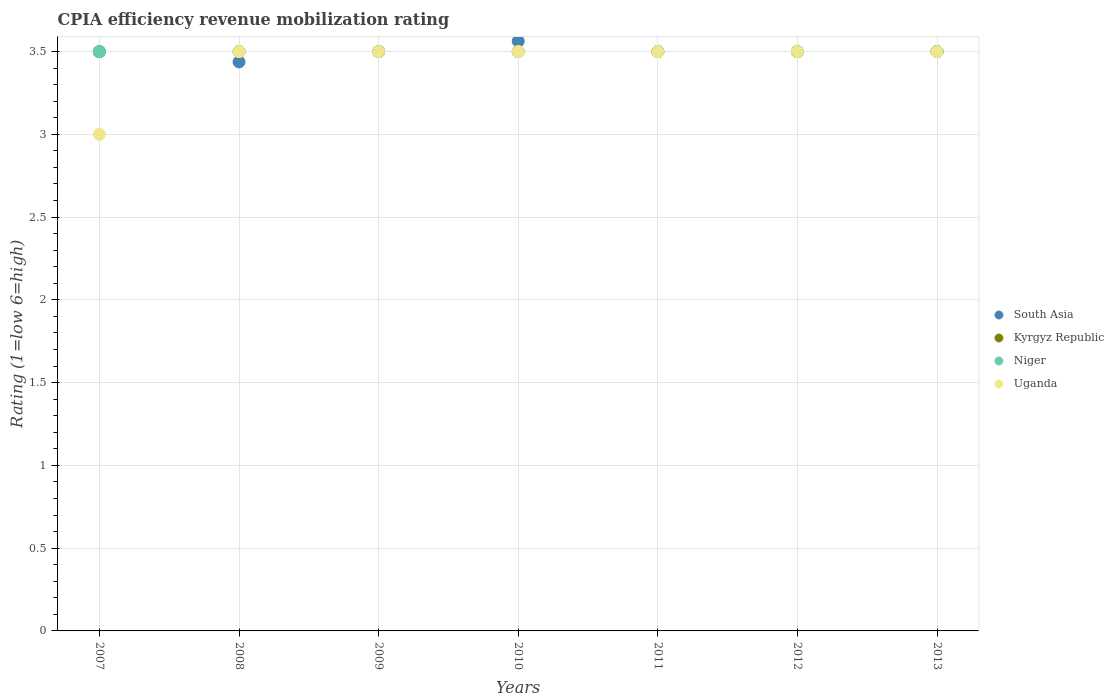Is the number of dotlines equal to the number of legend labels?
Provide a short and direct response. Yes. What is the CPIA rating in Uganda in 2013?
Provide a short and direct response. 3.5. Across all years, what is the maximum CPIA rating in South Asia?
Ensure brevity in your answer.  3.56. Across all years, what is the minimum CPIA rating in Uganda?
Keep it short and to the point. 3. In which year was the CPIA rating in Uganda minimum?
Provide a succinct answer. 2007. What is the difference between the CPIA rating in Niger in 2009 and that in 2010?
Give a very brief answer. 0. What is the difference between the CPIA rating in Niger in 2013 and the CPIA rating in Kyrgyz Republic in 2008?
Ensure brevity in your answer.  0. What is the average CPIA rating in Uganda per year?
Offer a very short reply. 3.43. In how many years, is the CPIA rating in South Asia greater than 2.8?
Provide a short and direct response. 7. What is the ratio of the CPIA rating in Kyrgyz Republic in 2009 to that in 2011?
Your answer should be very brief. 1. Is the CPIA rating in Uganda in 2007 less than that in 2010?
Keep it short and to the point. Yes. Is the difference between the CPIA rating in Uganda in 2010 and 2012 greater than the difference between the CPIA rating in South Asia in 2010 and 2012?
Keep it short and to the point. No. What is the difference between the highest and the lowest CPIA rating in Uganda?
Your response must be concise. 0.5. Does the CPIA rating in South Asia monotonically increase over the years?
Provide a succinct answer. No. What is the difference between two consecutive major ticks on the Y-axis?
Keep it short and to the point. 0.5. Does the graph contain any zero values?
Make the answer very short. No. Where does the legend appear in the graph?
Offer a very short reply. Center right. How many legend labels are there?
Ensure brevity in your answer.  4. How are the legend labels stacked?
Provide a short and direct response. Vertical. What is the title of the graph?
Offer a very short reply. CPIA efficiency revenue mobilization rating. What is the label or title of the X-axis?
Your answer should be compact. Years. What is the Rating (1=low 6=high) in South Asia in 2007?
Offer a terse response. 3.5. What is the Rating (1=low 6=high) in Kyrgyz Republic in 2007?
Your response must be concise. 3.5. What is the Rating (1=low 6=high) in Uganda in 2007?
Provide a short and direct response. 3. What is the Rating (1=low 6=high) of South Asia in 2008?
Make the answer very short. 3.44. What is the Rating (1=low 6=high) of Niger in 2008?
Your response must be concise. 3.5. What is the Rating (1=low 6=high) of Niger in 2009?
Your answer should be compact. 3.5. What is the Rating (1=low 6=high) of South Asia in 2010?
Your answer should be compact. 3.56. What is the Rating (1=low 6=high) in Kyrgyz Republic in 2010?
Ensure brevity in your answer.  3.5. What is the Rating (1=low 6=high) in Niger in 2010?
Offer a terse response. 3.5. What is the Rating (1=low 6=high) of Uganda in 2010?
Your answer should be very brief. 3.5. What is the Rating (1=low 6=high) in Uganda in 2011?
Your response must be concise. 3.5. What is the Rating (1=low 6=high) in South Asia in 2012?
Offer a terse response. 3.5. What is the Rating (1=low 6=high) of South Asia in 2013?
Keep it short and to the point. 3.5. What is the Rating (1=low 6=high) of Kyrgyz Republic in 2013?
Provide a succinct answer. 3.5. Across all years, what is the maximum Rating (1=low 6=high) of South Asia?
Your answer should be very brief. 3.56. Across all years, what is the maximum Rating (1=low 6=high) of Niger?
Ensure brevity in your answer.  3.5. Across all years, what is the maximum Rating (1=low 6=high) of Uganda?
Your response must be concise. 3.5. Across all years, what is the minimum Rating (1=low 6=high) of South Asia?
Your answer should be very brief. 3.44. Across all years, what is the minimum Rating (1=low 6=high) in Kyrgyz Republic?
Make the answer very short. 3.5. Across all years, what is the minimum Rating (1=low 6=high) in Uganda?
Offer a very short reply. 3. What is the total Rating (1=low 6=high) of Kyrgyz Republic in the graph?
Keep it short and to the point. 24.5. What is the difference between the Rating (1=low 6=high) of South Asia in 2007 and that in 2008?
Provide a succinct answer. 0.06. What is the difference between the Rating (1=low 6=high) in Kyrgyz Republic in 2007 and that in 2008?
Your answer should be compact. 0. What is the difference between the Rating (1=low 6=high) of South Asia in 2007 and that in 2009?
Provide a short and direct response. 0. What is the difference between the Rating (1=low 6=high) in Kyrgyz Republic in 2007 and that in 2009?
Provide a succinct answer. 0. What is the difference between the Rating (1=low 6=high) in Niger in 2007 and that in 2009?
Provide a succinct answer. 0. What is the difference between the Rating (1=low 6=high) in Uganda in 2007 and that in 2009?
Provide a short and direct response. -0.5. What is the difference between the Rating (1=low 6=high) in South Asia in 2007 and that in 2010?
Ensure brevity in your answer.  -0.06. What is the difference between the Rating (1=low 6=high) in Niger in 2007 and that in 2010?
Your response must be concise. 0. What is the difference between the Rating (1=low 6=high) of Uganda in 2007 and that in 2010?
Give a very brief answer. -0.5. What is the difference between the Rating (1=low 6=high) of South Asia in 2007 and that in 2011?
Provide a succinct answer. 0. What is the difference between the Rating (1=low 6=high) of Niger in 2007 and that in 2011?
Offer a terse response. 0. What is the difference between the Rating (1=low 6=high) in South Asia in 2007 and that in 2012?
Give a very brief answer. 0. What is the difference between the Rating (1=low 6=high) of Kyrgyz Republic in 2007 and that in 2012?
Offer a terse response. 0. What is the difference between the Rating (1=low 6=high) of Niger in 2007 and that in 2012?
Your answer should be very brief. 0. What is the difference between the Rating (1=low 6=high) in Uganda in 2007 and that in 2013?
Your answer should be very brief. -0.5. What is the difference between the Rating (1=low 6=high) in South Asia in 2008 and that in 2009?
Your answer should be compact. -0.06. What is the difference between the Rating (1=low 6=high) in Kyrgyz Republic in 2008 and that in 2009?
Make the answer very short. 0. What is the difference between the Rating (1=low 6=high) of Niger in 2008 and that in 2009?
Your answer should be very brief. 0. What is the difference between the Rating (1=low 6=high) of South Asia in 2008 and that in 2010?
Offer a terse response. -0.12. What is the difference between the Rating (1=low 6=high) of South Asia in 2008 and that in 2011?
Provide a succinct answer. -0.06. What is the difference between the Rating (1=low 6=high) of Kyrgyz Republic in 2008 and that in 2011?
Your answer should be compact. 0. What is the difference between the Rating (1=low 6=high) of Niger in 2008 and that in 2011?
Provide a succinct answer. 0. What is the difference between the Rating (1=low 6=high) of South Asia in 2008 and that in 2012?
Ensure brevity in your answer.  -0.06. What is the difference between the Rating (1=low 6=high) in Kyrgyz Republic in 2008 and that in 2012?
Your response must be concise. 0. What is the difference between the Rating (1=low 6=high) in South Asia in 2008 and that in 2013?
Offer a very short reply. -0.06. What is the difference between the Rating (1=low 6=high) of Niger in 2008 and that in 2013?
Give a very brief answer. 0. What is the difference between the Rating (1=low 6=high) of South Asia in 2009 and that in 2010?
Provide a short and direct response. -0.06. What is the difference between the Rating (1=low 6=high) of Kyrgyz Republic in 2009 and that in 2011?
Your answer should be very brief. 0. What is the difference between the Rating (1=low 6=high) of Niger in 2009 and that in 2011?
Ensure brevity in your answer.  0. What is the difference between the Rating (1=low 6=high) of Uganda in 2009 and that in 2011?
Keep it short and to the point. 0. What is the difference between the Rating (1=low 6=high) of Uganda in 2009 and that in 2012?
Offer a terse response. 0. What is the difference between the Rating (1=low 6=high) in Kyrgyz Republic in 2009 and that in 2013?
Provide a short and direct response. 0. What is the difference between the Rating (1=low 6=high) of Uganda in 2009 and that in 2013?
Your answer should be compact. 0. What is the difference between the Rating (1=low 6=high) of South Asia in 2010 and that in 2011?
Offer a very short reply. 0.06. What is the difference between the Rating (1=low 6=high) in Niger in 2010 and that in 2011?
Provide a short and direct response. 0. What is the difference between the Rating (1=low 6=high) of South Asia in 2010 and that in 2012?
Ensure brevity in your answer.  0.06. What is the difference between the Rating (1=low 6=high) in Kyrgyz Republic in 2010 and that in 2012?
Your response must be concise. 0. What is the difference between the Rating (1=low 6=high) in Niger in 2010 and that in 2012?
Ensure brevity in your answer.  0. What is the difference between the Rating (1=low 6=high) in Uganda in 2010 and that in 2012?
Offer a terse response. 0. What is the difference between the Rating (1=low 6=high) in South Asia in 2010 and that in 2013?
Offer a terse response. 0.06. What is the difference between the Rating (1=low 6=high) of Kyrgyz Republic in 2010 and that in 2013?
Keep it short and to the point. 0. What is the difference between the Rating (1=low 6=high) of Niger in 2010 and that in 2013?
Provide a short and direct response. 0. What is the difference between the Rating (1=low 6=high) of Uganda in 2010 and that in 2013?
Keep it short and to the point. 0. What is the difference between the Rating (1=low 6=high) of South Asia in 2011 and that in 2012?
Offer a very short reply. 0. What is the difference between the Rating (1=low 6=high) of Kyrgyz Republic in 2011 and that in 2012?
Your answer should be compact. 0. What is the difference between the Rating (1=low 6=high) of Uganda in 2011 and that in 2012?
Offer a very short reply. 0. What is the difference between the Rating (1=low 6=high) of South Asia in 2011 and that in 2013?
Provide a succinct answer. 0. What is the difference between the Rating (1=low 6=high) of Kyrgyz Republic in 2011 and that in 2013?
Keep it short and to the point. 0. What is the difference between the Rating (1=low 6=high) of Uganda in 2011 and that in 2013?
Provide a short and direct response. 0. What is the difference between the Rating (1=low 6=high) in South Asia in 2012 and that in 2013?
Offer a terse response. 0. What is the difference between the Rating (1=low 6=high) in Uganda in 2012 and that in 2013?
Provide a succinct answer. 0. What is the difference between the Rating (1=low 6=high) in South Asia in 2007 and the Rating (1=low 6=high) in Niger in 2008?
Provide a succinct answer. 0. What is the difference between the Rating (1=low 6=high) in South Asia in 2007 and the Rating (1=low 6=high) in Uganda in 2008?
Give a very brief answer. 0. What is the difference between the Rating (1=low 6=high) in Kyrgyz Republic in 2007 and the Rating (1=low 6=high) in Niger in 2008?
Your answer should be compact. 0. What is the difference between the Rating (1=low 6=high) of Kyrgyz Republic in 2007 and the Rating (1=low 6=high) of Uganda in 2008?
Your answer should be very brief. 0. What is the difference between the Rating (1=low 6=high) in Niger in 2007 and the Rating (1=low 6=high) in Uganda in 2008?
Ensure brevity in your answer.  0. What is the difference between the Rating (1=low 6=high) in South Asia in 2007 and the Rating (1=low 6=high) in Kyrgyz Republic in 2009?
Your response must be concise. 0. What is the difference between the Rating (1=low 6=high) of South Asia in 2007 and the Rating (1=low 6=high) of Uganda in 2009?
Offer a very short reply. 0. What is the difference between the Rating (1=low 6=high) of Kyrgyz Republic in 2007 and the Rating (1=low 6=high) of Uganda in 2009?
Your response must be concise. 0. What is the difference between the Rating (1=low 6=high) in South Asia in 2007 and the Rating (1=low 6=high) in Kyrgyz Republic in 2010?
Offer a very short reply. 0. What is the difference between the Rating (1=low 6=high) of Niger in 2007 and the Rating (1=low 6=high) of Uganda in 2010?
Your answer should be very brief. 0. What is the difference between the Rating (1=low 6=high) of South Asia in 2007 and the Rating (1=low 6=high) of Niger in 2011?
Your answer should be very brief. 0. What is the difference between the Rating (1=low 6=high) in South Asia in 2007 and the Rating (1=low 6=high) in Uganda in 2011?
Keep it short and to the point. 0. What is the difference between the Rating (1=low 6=high) of South Asia in 2007 and the Rating (1=low 6=high) of Niger in 2012?
Provide a succinct answer. 0. What is the difference between the Rating (1=low 6=high) of South Asia in 2007 and the Rating (1=low 6=high) of Uganda in 2012?
Ensure brevity in your answer.  0. What is the difference between the Rating (1=low 6=high) of Kyrgyz Republic in 2007 and the Rating (1=low 6=high) of Niger in 2012?
Offer a terse response. 0. What is the difference between the Rating (1=low 6=high) of South Asia in 2007 and the Rating (1=low 6=high) of Niger in 2013?
Ensure brevity in your answer.  0. What is the difference between the Rating (1=low 6=high) of South Asia in 2007 and the Rating (1=low 6=high) of Uganda in 2013?
Offer a terse response. 0. What is the difference between the Rating (1=low 6=high) of Kyrgyz Republic in 2007 and the Rating (1=low 6=high) of Uganda in 2013?
Your answer should be very brief. 0. What is the difference between the Rating (1=low 6=high) in Niger in 2007 and the Rating (1=low 6=high) in Uganda in 2013?
Offer a very short reply. 0. What is the difference between the Rating (1=low 6=high) in South Asia in 2008 and the Rating (1=low 6=high) in Kyrgyz Republic in 2009?
Your answer should be compact. -0.06. What is the difference between the Rating (1=low 6=high) in South Asia in 2008 and the Rating (1=low 6=high) in Niger in 2009?
Provide a short and direct response. -0.06. What is the difference between the Rating (1=low 6=high) in South Asia in 2008 and the Rating (1=low 6=high) in Uganda in 2009?
Provide a succinct answer. -0.06. What is the difference between the Rating (1=low 6=high) in Kyrgyz Republic in 2008 and the Rating (1=low 6=high) in Uganda in 2009?
Ensure brevity in your answer.  0. What is the difference between the Rating (1=low 6=high) of Niger in 2008 and the Rating (1=low 6=high) of Uganda in 2009?
Offer a terse response. 0. What is the difference between the Rating (1=low 6=high) of South Asia in 2008 and the Rating (1=low 6=high) of Kyrgyz Republic in 2010?
Make the answer very short. -0.06. What is the difference between the Rating (1=low 6=high) of South Asia in 2008 and the Rating (1=low 6=high) of Niger in 2010?
Keep it short and to the point. -0.06. What is the difference between the Rating (1=low 6=high) in South Asia in 2008 and the Rating (1=low 6=high) in Uganda in 2010?
Ensure brevity in your answer.  -0.06. What is the difference between the Rating (1=low 6=high) in Kyrgyz Republic in 2008 and the Rating (1=low 6=high) in Uganda in 2010?
Keep it short and to the point. 0. What is the difference between the Rating (1=low 6=high) in Niger in 2008 and the Rating (1=low 6=high) in Uganda in 2010?
Your response must be concise. 0. What is the difference between the Rating (1=low 6=high) of South Asia in 2008 and the Rating (1=low 6=high) of Kyrgyz Republic in 2011?
Offer a terse response. -0.06. What is the difference between the Rating (1=low 6=high) in South Asia in 2008 and the Rating (1=low 6=high) in Niger in 2011?
Your answer should be compact. -0.06. What is the difference between the Rating (1=low 6=high) of South Asia in 2008 and the Rating (1=low 6=high) of Uganda in 2011?
Your response must be concise. -0.06. What is the difference between the Rating (1=low 6=high) in Kyrgyz Republic in 2008 and the Rating (1=low 6=high) in Niger in 2011?
Offer a very short reply. 0. What is the difference between the Rating (1=low 6=high) of South Asia in 2008 and the Rating (1=low 6=high) of Kyrgyz Republic in 2012?
Keep it short and to the point. -0.06. What is the difference between the Rating (1=low 6=high) of South Asia in 2008 and the Rating (1=low 6=high) of Niger in 2012?
Provide a succinct answer. -0.06. What is the difference between the Rating (1=low 6=high) in South Asia in 2008 and the Rating (1=low 6=high) in Uganda in 2012?
Keep it short and to the point. -0.06. What is the difference between the Rating (1=low 6=high) in Kyrgyz Republic in 2008 and the Rating (1=low 6=high) in Uganda in 2012?
Your answer should be very brief. 0. What is the difference between the Rating (1=low 6=high) of Niger in 2008 and the Rating (1=low 6=high) of Uganda in 2012?
Provide a short and direct response. 0. What is the difference between the Rating (1=low 6=high) of South Asia in 2008 and the Rating (1=low 6=high) of Kyrgyz Republic in 2013?
Your answer should be compact. -0.06. What is the difference between the Rating (1=low 6=high) of South Asia in 2008 and the Rating (1=low 6=high) of Niger in 2013?
Keep it short and to the point. -0.06. What is the difference between the Rating (1=low 6=high) of South Asia in 2008 and the Rating (1=low 6=high) of Uganda in 2013?
Your response must be concise. -0.06. What is the difference between the Rating (1=low 6=high) in Kyrgyz Republic in 2008 and the Rating (1=low 6=high) in Niger in 2013?
Provide a succinct answer. 0. What is the difference between the Rating (1=low 6=high) of Niger in 2008 and the Rating (1=low 6=high) of Uganda in 2013?
Your response must be concise. 0. What is the difference between the Rating (1=low 6=high) of South Asia in 2009 and the Rating (1=low 6=high) of Kyrgyz Republic in 2010?
Offer a terse response. 0. What is the difference between the Rating (1=low 6=high) in Kyrgyz Republic in 2009 and the Rating (1=low 6=high) in Uganda in 2010?
Ensure brevity in your answer.  0. What is the difference between the Rating (1=low 6=high) in Kyrgyz Republic in 2009 and the Rating (1=low 6=high) in Uganda in 2011?
Give a very brief answer. 0. What is the difference between the Rating (1=low 6=high) of Niger in 2009 and the Rating (1=low 6=high) of Uganda in 2011?
Your answer should be very brief. 0. What is the difference between the Rating (1=low 6=high) of South Asia in 2009 and the Rating (1=low 6=high) of Kyrgyz Republic in 2012?
Offer a terse response. 0. What is the difference between the Rating (1=low 6=high) of South Asia in 2009 and the Rating (1=low 6=high) of Niger in 2012?
Your answer should be compact. 0. What is the difference between the Rating (1=low 6=high) of South Asia in 2009 and the Rating (1=low 6=high) of Uganda in 2012?
Give a very brief answer. 0. What is the difference between the Rating (1=low 6=high) in Kyrgyz Republic in 2009 and the Rating (1=low 6=high) in Niger in 2012?
Your answer should be very brief. 0. What is the difference between the Rating (1=low 6=high) in South Asia in 2009 and the Rating (1=low 6=high) in Kyrgyz Republic in 2013?
Keep it short and to the point. 0. What is the difference between the Rating (1=low 6=high) of Kyrgyz Republic in 2009 and the Rating (1=low 6=high) of Niger in 2013?
Ensure brevity in your answer.  0. What is the difference between the Rating (1=low 6=high) in Niger in 2009 and the Rating (1=low 6=high) in Uganda in 2013?
Keep it short and to the point. 0. What is the difference between the Rating (1=low 6=high) in South Asia in 2010 and the Rating (1=low 6=high) in Kyrgyz Republic in 2011?
Your answer should be compact. 0.06. What is the difference between the Rating (1=low 6=high) in South Asia in 2010 and the Rating (1=low 6=high) in Niger in 2011?
Your answer should be compact. 0.06. What is the difference between the Rating (1=low 6=high) of South Asia in 2010 and the Rating (1=low 6=high) of Uganda in 2011?
Provide a short and direct response. 0.06. What is the difference between the Rating (1=low 6=high) of Kyrgyz Republic in 2010 and the Rating (1=low 6=high) of Uganda in 2011?
Offer a terse response. 0. What is the difference between the Rating (1=low 6=high) in South Asia in 2010 and the Rating (1=low 6=high) in Kyrgyz Republic in 2012?
Give a very brief answer. 0.06. What is the difference between the Rating (1=low 6=high) of South Asia in 2010 and the Rating (1=low 6=high) of Niger in 2012?
Ensure brevity in your answer.  0.06. What is the difference between the Rating (1=low 6=high) of South Asia in 2010 and the Rating (1=low 6=high) of Uganda in 2012?
Offer a very short reply. 0.06. What is the difference between the Rating (1=low 6=high) in Kyrgyz Republic in 2010 and the Rating (1=low 6=high) in Niger in 2012?
Your response must be concise. 0. What is the difference between the Rating (1=low 6=high) of South Asia in 2010 and the Rating (1=low 6=high) of Kyrgyz Republic in 2013?
Keep it short and to the point. 0.06. What is the difference between the Rating (1=low 6=high) of South Asia in 2010 and the Rating (1=low 6=high) of Niger in 2013?
Your response must be concise. 0.06. What is the difference between the Rating (1=low 6=high) in South Asia in 2010 and the Rating (1=low 6=high) in Uganda in 2013?
Ensure brevity in your answer.  0.06. What is the difference between the Rating (1=low 6=high) of Kyrgyz Republic in 2010 and the Rating (1=low 6=high) of Niger in 2013?
Your answer should be very brief. 0. What is the difference between the Rating (1=low 6=high) in Niger in 2010 and the Rating (1=low 6=high) in Uganda in 2013?
Ensure brevity in your answer.  0. What is the difference between the Rating (1=low 6=high) in Kyrgyz Republic in 2011 and the Rating (1=low 6=high) in Niger in 2012?
Offer a terse response. 0. What is the difference between the Rating (1=low 6=high) of South Asia in 2011 and the Rating (1=low 6=high) of Kyrgyz Republic in 2013?
Offer a terse response. 0. What is the difference between the Rating (1=low 6=high) in South Asia in 2011 and the Rating (1=low 6=high) in Uganda in 2013?
Ensure brevity in your answer.  0. What is the difference between the Rating (1=low 6=high) in South Asia in 2012 and the Rating (1=low 6=high) in Kyrgyz Republic in 2013?
Your answer should be very brief. 0. What is the difference between the Rating (1=low 6=high) in Kyrgyz Republic in 2012 and the Rating (1=low 6=high) in Niger in 2013?
Give a very brief answer. 0. What is the difference between the Rating (1=low 6=high) in Kyrgyz Republic in 2012 and the Rating (1=low 6=high) in Uganda in 2013?
Offer a terse response. 0. What is the average Rating (1=low 6=high) in Uganda per year?
Your answer should be very brief. 3.43. In the year 2007, what is the difference between the Rating (1=low 6=high) of South Asia and Rating (1=low 6=high) of Uganda?
Offer a very short reply. 0.5. In the year 2007, what is the difference between the Rating (1=low 6=high) of Kyrgyz Republic and Rating (1=low 6=high) of Niger?
Offer a very short reply. 0. In the year 2007, what is the difference between the Rating (1=low 6=high) in Niger and Rating (1=low 6=high) in Uganda?
Provide a succinct answer. 0.5. In the year 2008, what is the difference between the Rating (1=low 6=high) of South Asia and Rating (1=low 6=high) of Kyrgyz Republic?
Offer a very short reply. -0.06. In the year 2008, what is the difference between the Rating (1=low 6=high) in South Asia and Rating (1=low 6=high) in Niger?
Offer a terse response. -0.06. In the year 2008, what is the difference between the Rating (1=low 6=high) of South Asia and Rating (1=low 6=high) of Uganda?
Offer a terse response. -0.06. In the year 2008, what is the difference between the Rating (1=low 6=high) of Kyrgyz Republic and Rating (1=low 6=high) of Uganda?
Your answer should be very brief. 0. In the year 2009, what is the difference between the Rating (1=low 6=high) in South Asia and Rating (1=low 6=high) in Kyrgyz Republic?
Make the answer very short. 0. In the year 2009, what is the difference between the Rating (1=low 6=high) of South Asia and Rating (1=low 6=high) of Niger?
Your answer should be compact. 0. In the year 2010, what is the difference between the Rating (1=low 6=high) of South Asia and Rating (1=low 6=high) of Kyrgyz Republic?
Keep it short and to the point. 0.06. In the year 2010, what is the difference between the Rating (1=low 6=high) of South Asia and Rating (1=low 6=high) of Niger?
Give a very brief answer. 0.06. In the year 2010, what is the difference between the Rating (1=low 6=high) in South Asia and Rating (1=low 6=high) in Uganda?
Your answer should be compact. 0.06. In the year 2010, what is the difference between the Rating (1=low 6=high) of Kyrgyz Republic and Rating (1=low 6=high) of Niger?
Your answer should be compact. 0. In the year 2011, what is the difference between the Rating (1=low 6=high) in South Asia and Rating (1=low 6=high) in Uganda?
Make the answer very short. 0. In the year 2011, what is the difference between the Rating (1=low 6=high) in Kyrgyz Republic and Rating (1=low 6=high) in Niger?
Offer a very short reply. 0. In the year 2012, what is the difference between the Rating (1=low 6=high) of South Asia and Rating (1=low 6=high) of Niger?
Offer a very short reply. 0. In the year 2012, what is the difference between the Rating (1=low 6=high) of South Asia and Rating (1=low 6=high) of Uganda?
Your answer should be very brief. 0. In the year 2012, what is the difference between the Rating (1=low 6=high) in Kyrgyz Republic and Rating (1=low 6=high) in Uganda?
Your answer should be very brief. 0. In the year 2013, what is the difference between the Rating (1=low 6=high) of South Asia and Rating (1=low 6=high) of Niger?
Offer a terse response. 0. In the year 2013, what is the difference between the Rating (1=low 6=high) in South Asia and Rating (1=low 6=high) in Uganda?
Ensure brevity in your answer.  0. In the year 2013, what is the difference between the Rating (1=low 6=high) of Kyrgyz Republic and Rating (1=low 6=high) of Niger?
Ensure brevity in your answer.  0. In the year 2013, what is the difference between the Rating (1=low 6=high) in Niger and Rating (1=low 6=high) in Uganda?
Provide a short and direct response. 0. What is the ratio of the Rating (1=low 6=high) in South Asia in 2007 to that in 2008?
Provide a short and direct response. 1.02. What is the ratio of the Rating (1=low 6=high) in Niger in 2007 to that in 2008?
Make the answer very short. 1. What is the ratio of the Rating (1=low 6=high) in Uganda in 2007 to that in 2008?
Provide a short and direct response. 0.86. What is the ratio of the Rating (1=low 6=high) of South Asia in 2007 to that in 2009?
Ensure brevity in your answer.  1. What is the ratio of the Rating (1=low 6=high) of Niger in 2007 to that in 2009?
Ensure brevity in your answer.  1. What is the ratio of the Rating (1=low 6=high) of South Asia in 2007 to that in 2010?
Your response must be concise. 0.98. What is the ratio of the Rating (1=low 6=high) of Uganda in 2007 to that in 2010?
Offer a very short reply. 0.86. What is the ratio of the Rating (1=low 6=high) of South Asia in 2007 to that in 2011?
Your response must be concise. 1. What is the ratio of the Rating (1=low 6=high) of Kyrgyz Republic in 2007 to that in 2011?
Provide a short and direct response. 1. What is the ratio of the Rating (1=low 6=high) of Niger in 2007 to that in 2011?
Your answer should be very brief. 1. What is the ratio of the Rating (1=low 6=high) of Uganda in 2007 to that in 2011?
Your answer should be compact. 0.86. What is the ratio of the Rating (1=low 6=high) in South Asia in 2007 to that in 2012?
Make the answer very short. 1. What is the ratio of the Rating (1=low 6=high) in Kyrgyz Republic in 2007 to that in 2012?
Make the answer very short. 1. What is the ratio of the Rating (1=low 6=high) of Niger in 2007 to that in 2012?
Provide a succinct answer. 1. What is the ratio of the Rating (1=low 6=high) of Uganda in 2007 to that in 2012?
Offer a terse response. 0.86. What is the ratio of the Rating (1=low 6=high) in Uganda in 2007 to that in 2013?
Your answer should be compact. 0.86. What is the ratio of the Rating (1=low 6=high) of South Asia in 2008 to that in 2009?
Make the answer very short. 0.98. What is the ratio of the Rating (1=low 6=high) of South Asia in 2008 to that in 2010?
Your answer should be very brief. 0.96. What is the ratio of the Rating (1=low 6=high) of Niger in 2008 to that in 2010?
Give a very brief answer. 1. What is the ratio of the Rating (1=low 6=high) in South Asia in 2008 to that in 2011?
Ensure brevity in your answer.  0.98. What is the ratio of the Rating (1=low 6=high) of South Asia in 2008 to that in 2012?
Offer a terse response. 0.98. What is the ratio of the Rating (1=low 6=high) of Kyrgyz Republic in 2008 to that in 2012?
Your response must be concise. 1. What is the ratio of the Rating (1=low 6=high) of South Asia in 2008 to that in 2013?
Offer a very short reply. 0.98. What is the ratio of the Rating (1=low 6=high) in Kyrgyz Republic in 2008 to that in 2013?
Offer a very short reply. 1. What is the ratio of the Rating (1=low 6=high) in South Asia in 2009 to that in 2010?
Keep it short and to the point. 0.98. What is the ratio of the Rating (1=low 6=high) in South Asia in 2009 to that in 2011?
Provide a succinct answer. 1. What is the ratio of the Rating (1=low 6=high) of Kyrgyz Republic in 2009 to that in 2011?
Offer a very short reply. 1. What is the ratio of the Rating (1=low 6=high) of Niger in 2009 to that in 2011?
Make the answer very short. 1. What is the ratio of the Rating (1=low 6=high) of Niger in 2009 to that in 2012?
Provide a succinct answer. 1. What is the ratio of the Rating (1=low 6=high) of Kyrgyz Republic in 2009 to that in 2013?
Your answer should be very brief. 1. What is the ratio of the Rating (1=low 6=high) of Uganda in 2009 to that in 2013?
Offer a terse response. 1. What is the ratio of the Rating (1=low 6=high) in South Asia in 2010 to that in 2011?
Your answer should be very brief. 1.02. What is the ratio of the Rating (1=low 6=high) in South Asia in 2010 to that in 2012?
Make the answer very short. 1.02. What is the ratio of the Rating (1=low 6=high) of South Asia in 2010 to that in 2013?
Keep it short and to the point. 1.02. What is the ratio of the Rating (1=low 6=high) in Kyrgyz Republic in 2010 to that in 2013?
Provide a short and direct response. 1. What is the ratio of the Rating (1=low 6=high) of Niger in 2010 to that in 2013?
Ensure brevity in your answer.  1. What is the ratio of the Rating (1=low 6=high) of Niger in 2011 to that in 2012?
Keep it short and to the point. 1. What is the ratio of the Rating (1=low 6=high) in South Asia in 2011 to that in 2013?
Provide a short and direct response. 1. What is the ratio of the Rating (1=low 6=high) of Uganda in 2011 to that in 2013?
Give a very brief answer. 1. What is the ratio of the Rating (1=low 6=high) in Uganda in 2012 to that in 2013?
Your answer should be compact. 1. What is the difference between the highest and the second highest Rating (1=low 6=high) in South Asia?
Give a very brief answer. 0.06. What is the difference between the highest and the second highest Rating (1=low 6=high) of Kyrgyz Republic?
Ensure brevity in your answer.  0. What is the difference between the highest and the lowest Rating (1=low 6=high) of South Asia?
Make the answer very short. 0.12. What is the difference between the highest and the lowest Rating (1=low 6=high) in Niger?
Offer a very short reply. 0. 